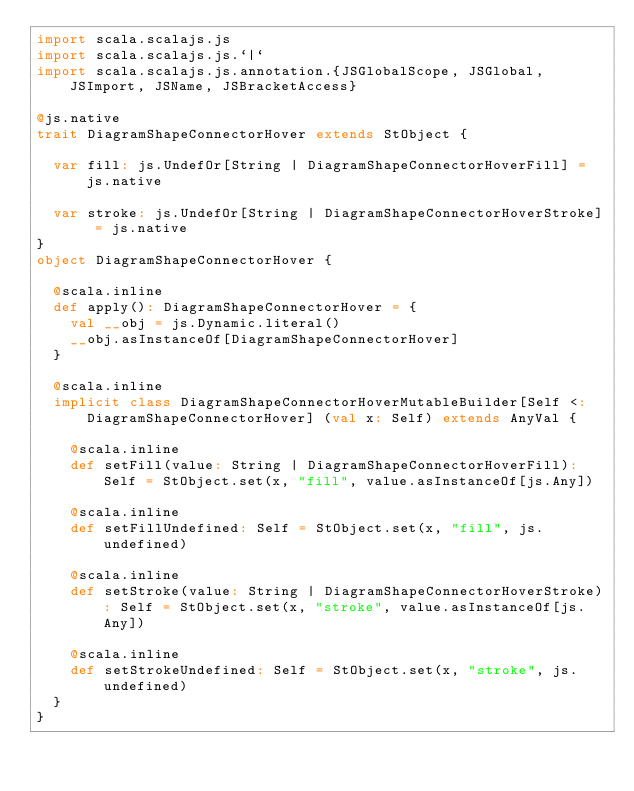<code> <loc_0><loc_0><loc_500><loc_500><_Scala_>import scala.scalajs.js
import scala.scalajs.js.`|`
import scala.scalajs.js.annotation.{JSGlobalScope, JSGlobal, JSImport, JSName, JSBracketAccess}

@js.native
trait DiagramShapeConnectorHover extends StObject {
  
  var fill: js.UndefOr[String | DiagramShapeConnectorHoverFill] = js.native
  
  var stroke: js.UndefOr[String | DiagramShapeConnectorHoverStroke] = js.native
}
object DiagramShapeConnectorHover {
  
  @scala.inline
  def apply(): DiagramShapeConnectorHover = {
    val __obj = js.Dynamic.literal()
    __obj.asInstanceOf[DiagramShapeConnectorHover]
  }
  
  @scala.inline
  implicit class DiagramShapeConnectorHoverMutableBuilder[Self <: DiagramShapeConnectorHover] (val x: Self) extends AnyVal {
    
    @scala.inline
    def setFill(value: String | DiagramShapeConnectorHoverFill): Self = StObject.set(x, "fill", value.asInstanceOf[js.Any])
    
    @scala.inline
    def setFillUndefined: Self = StObject.set(x, "fill", js.undefined)
    
    @scala.inline
    def setStroke(value: String | DiagramShapeConnectorHoverStroke): Self = StObject.set(x, "stroke", value.asInstanceOf[js.Any])
    
    @scala.inline
    def setStrokeUndefined: Self = StObject.set(x, "stroke", js.undefined)
  }
}
</code> 